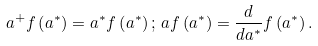Convert formula to latex. <formula><loc_0><loc_0><loc_500><loc_500>a ^ { + } f \left ( a ^ { \ast } \right ) = a ^ { \ast } f \left ( a ^ { \ast } \right ) ; \, a f \left ( a ^ { \ast } \right ) = \frac { d } { d a ^ { \ast } } f \left ( a ^ { \ast } \right ) .</formula> 